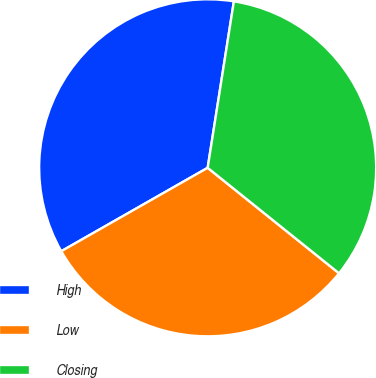Convert chart. <chart><loc_0><loc_0><loc_500><loc_500><pie_chart><fcel>High<fcel>Low<fcel>Closing<nl><fcel>35.73%<fcel>30.99%<fcel>33.28%<nl></chart> 